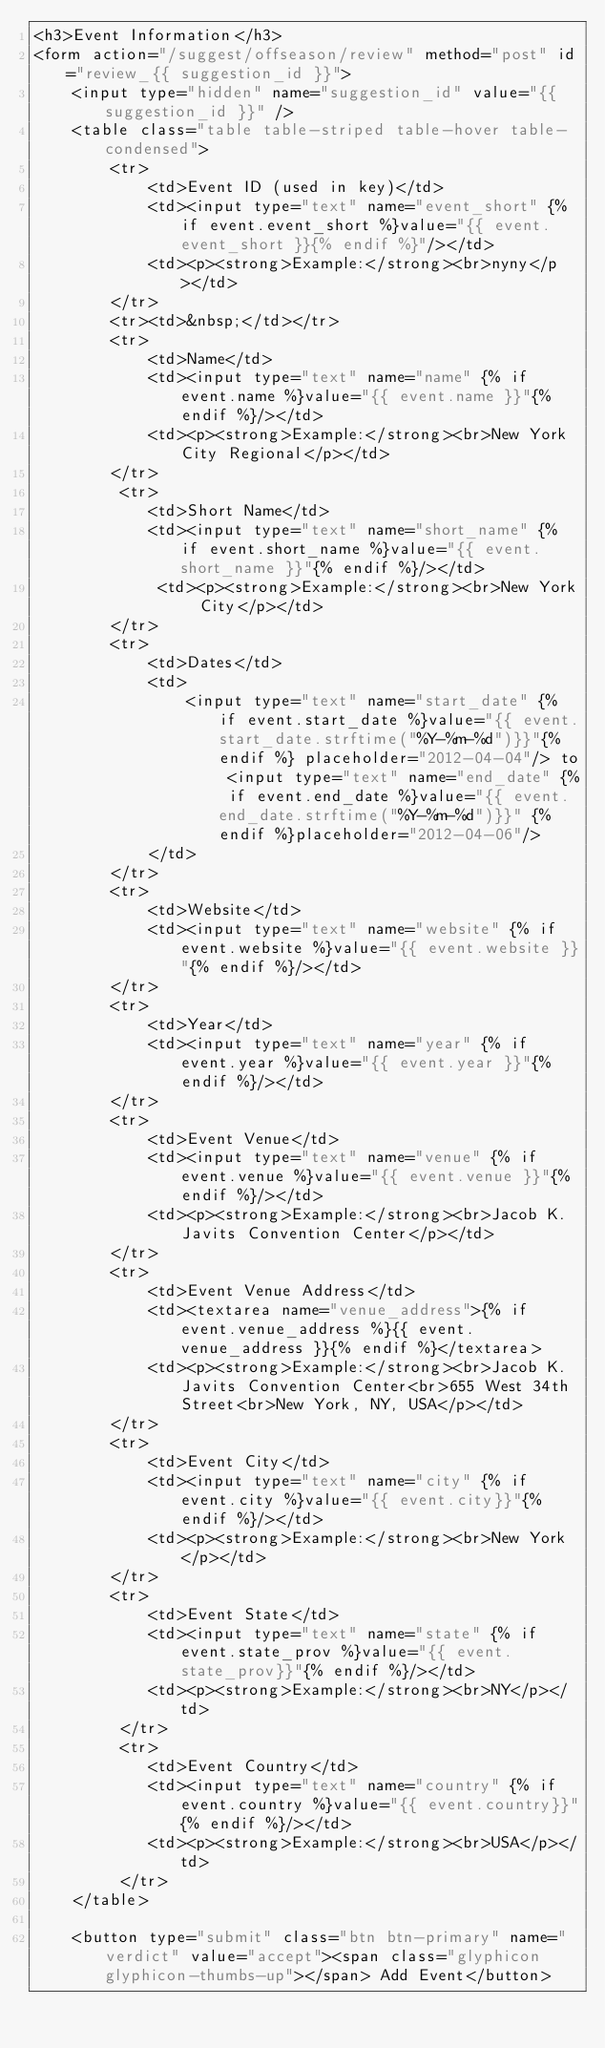<code> <loc_0><loc_0><loc_500><loc_500><_HTML_><h3>Event Information</h3>
<form action="/suggest/offseason/review" method="post" id="review_{{ suggestion_id }}">
    <input type="hidden" name="suggestion_id" value="{{ suggestion_id }}" />
    <table class="table table-striped table-hover table-condensed">
        <tr>
            <td>Event ID (used in key)</td>
            <td><input type="text" name="event_short" {% if event.event_short %}value="{{ event.event_short }}{% endif %}"/></td>
            <td><p><strong>Example:</strong><br>nyny</p></td>
        </tr>
        <tr><td>&nbsp;</td></tr>
        <tr>
            <td>Name</td>
            <td><input type="text" name="name" {% if event.name %}value="{{ event.name }}"{% endif %}/></td>
            <td><p><strong>Example:</strong><br>New York City Regional</p></td>
        </tr>
         <tr>
            <td>Short Name</td>
            <td><input type="text" name="short_name" {% if event.short_name %}value="{{ event.short_name }}"{% endif %}/></td>
             <td><p><strong>Example:</strong><br>New York City</p></td>
        </tr>
        <tr>
            <td>Dates</td>
            <td>
                <input type="text" name="start_date" {% if event.start_date %}value="{{ event.start_date.strftime("%Y-%m-%d")}}"{% endif %} placeholder="2012-04-04"/> to <input type="text" name="end_date" {% if event.end_date %}value="{{ event.end_date.strftime("%Y-%m-%d")}}" {% endif %}placeholder="2012-04-06"/>
            </td>
        </tr>
        <tr>
            <td>Website</td>
            <td><input type="text" name="website" {% if event.website %}value="{{ event.website }}"{% endif %}/></td>
        </tr>
        <tr>
            <td>Year</td>
            <td><input type="text" name="year" {% if event.year %}value="{{ event.year }}"{% endif %}/></td>
        </tr>
        <tr>
            <td>Event Venue</td>
            <td><input type="text" name="venue" {% if event.venue %}value="{{ event.venue }}"{% endif %}/></td>
            <td><p><strong>Example:</strong><br>Jacob K. Javits Convention Center</p></td>
        </tr>
        <tr>
            <td>Event Venue Address</td>
            <td><textarea name="venue_address">{% if event.venue_address %}{{ event.venue_address }}{% endif %}</textarea>
            <td><p><strong>Example:</strong><br>Jacob K. Javits Convention Center<br>655 West 34th Street<br>New York, NY, USA</p></td>
        </tr>
        <tr>
            <td>Event City</td>
            <td><input type="text" name="city" {% if event.city %}value="{{ event.city}}"{% endif %}/></td>
            <td><p><strong>Example:</strong><br>New York</p></td>
        </tr>
        <tr>
            <td>Event State</td>
            <td><input type="text" name="state" {% if event.state_prov %}value="{{ event.state_prov}}"{% endif %}/></td>
            <td><p><strong>Example:</strong><br>NY</p></td>
         </tr>
         <tr>
            <td>Event Country</td>
            <td><input type="text" name="country" {% if event.country %}value="{{ event.country}}"{% endif %}/></td>
            <td><p><strong>Example:</strong><br>USA</p></td>
         </tr>
    </table>

    <button type="submit" class="btn btn-primary" name="verdict" value="accept"><span class="glyphicon glyphicon-thumbs-up"></span> Add Event</button></code> 